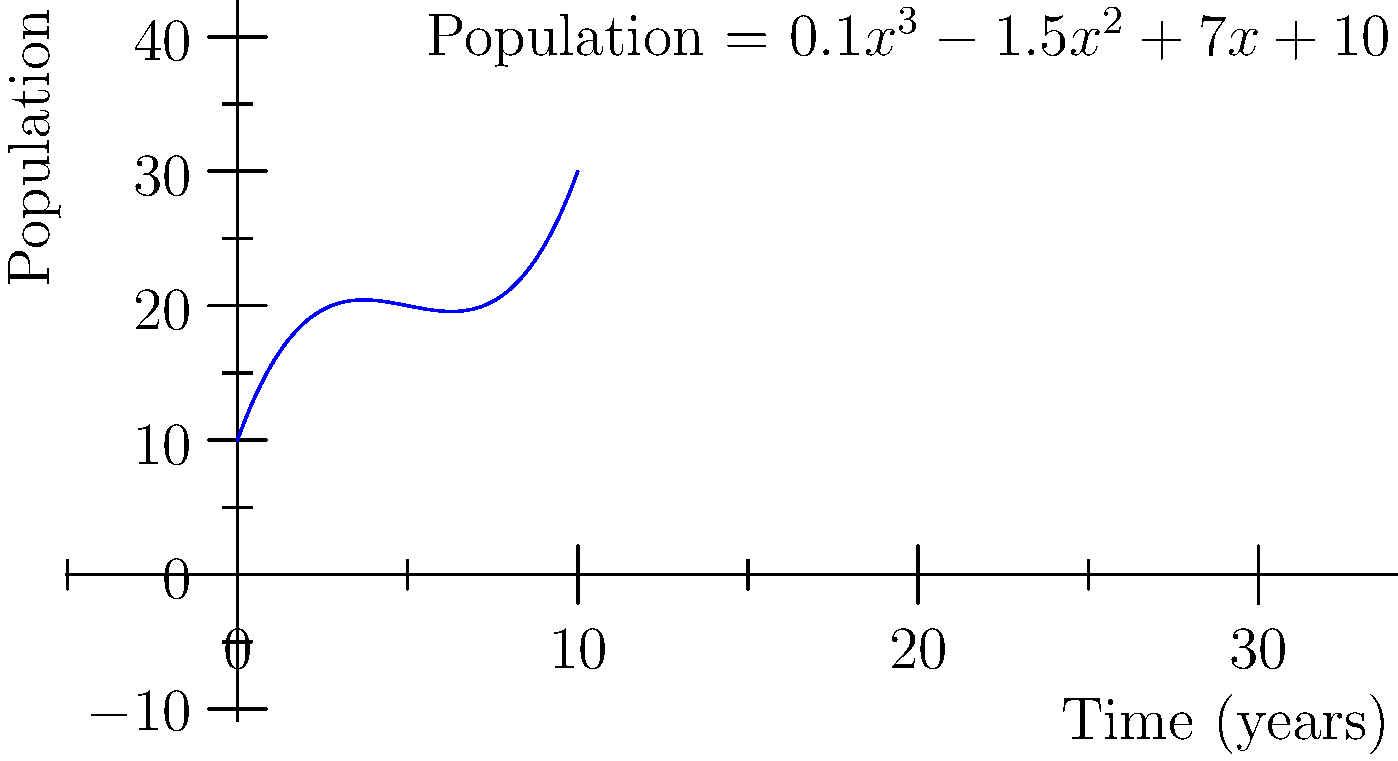As a computer scientist developing tracking technologies for animal behavior studies, you're working on a project to predict the population growth of a particular species over time. The graph shows a polynomial regression model of the population growth, represented by the equation $P(t) = 0.1t^3 - 1.5t^2 + 7t + 10$, where $P$ is the population size and $t$ is time in years. What is the expected population size after 5 years? To find the population size after 5 years, we need to evaluate the polynomial function $P(t)$ at $t = 5$. Let's follow these steps:

1) The given polynomial function is:
   $P(t) = 0.1t^3 - 1.5t^2 + 7t + 10$

2) Substitute $t = 5$ into the equation:
   $P(5) = 0.1(5^3) - 1.5(5^2) + 7(5) + 10$

3) Calculate each term:
   - $0.1(5^3) = 0.1(125) = 12.5$
   - $-1.5(5^2) = -1.5(25) = -37.5$
   - $7(5) = 35$
   - The constant term is 10

4) Sum up all the terms:
   $P(5) = 12.5 - 37.5 + 35 + 10 = 20$

Therefore, after 5 years, the expected population size is 20 individuals.
Answer: 20 individuals 